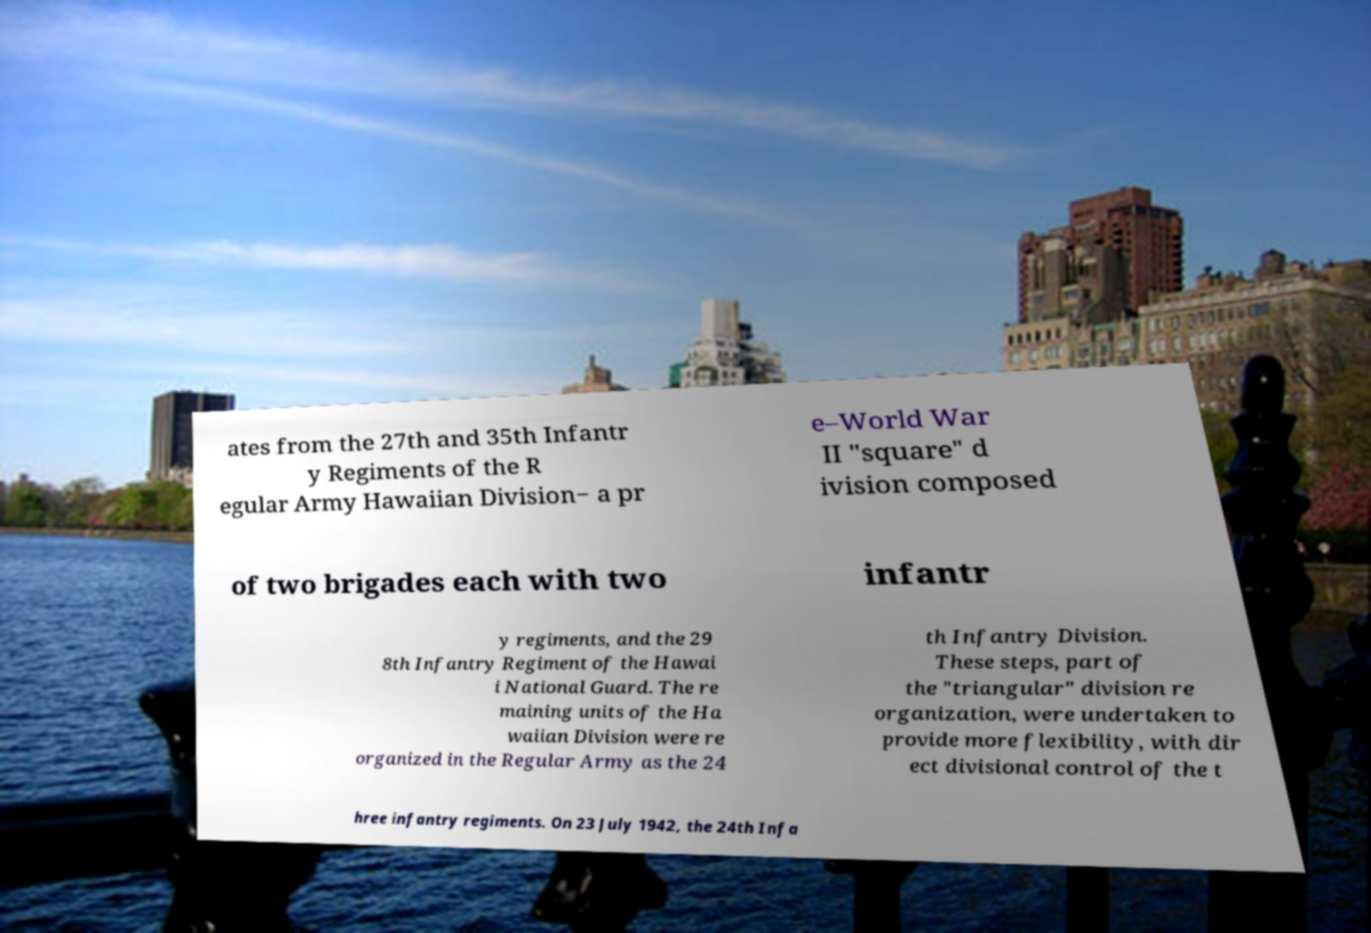I need the written content from this picture converted into text. Can you do that? ates from the 27th and 35th Infantr y Regiments of the R egular Army Hawaiian Division− a pr e–World War II "square" d ivision composed of two brigades each with two infantr y regiments, and the 29 8th Infantry Regiment of the Hawai i National Guard. The re maining units of the Ha waiian Division were re organized in the Regular Army as the 24 th Infantry Division. These steps, part of the "triangular" division re organization, were undertaken to provide more flexibility, with dir ect divisional control of the t hree infantry regiments. On 23 July 1942, the 24th Infa 